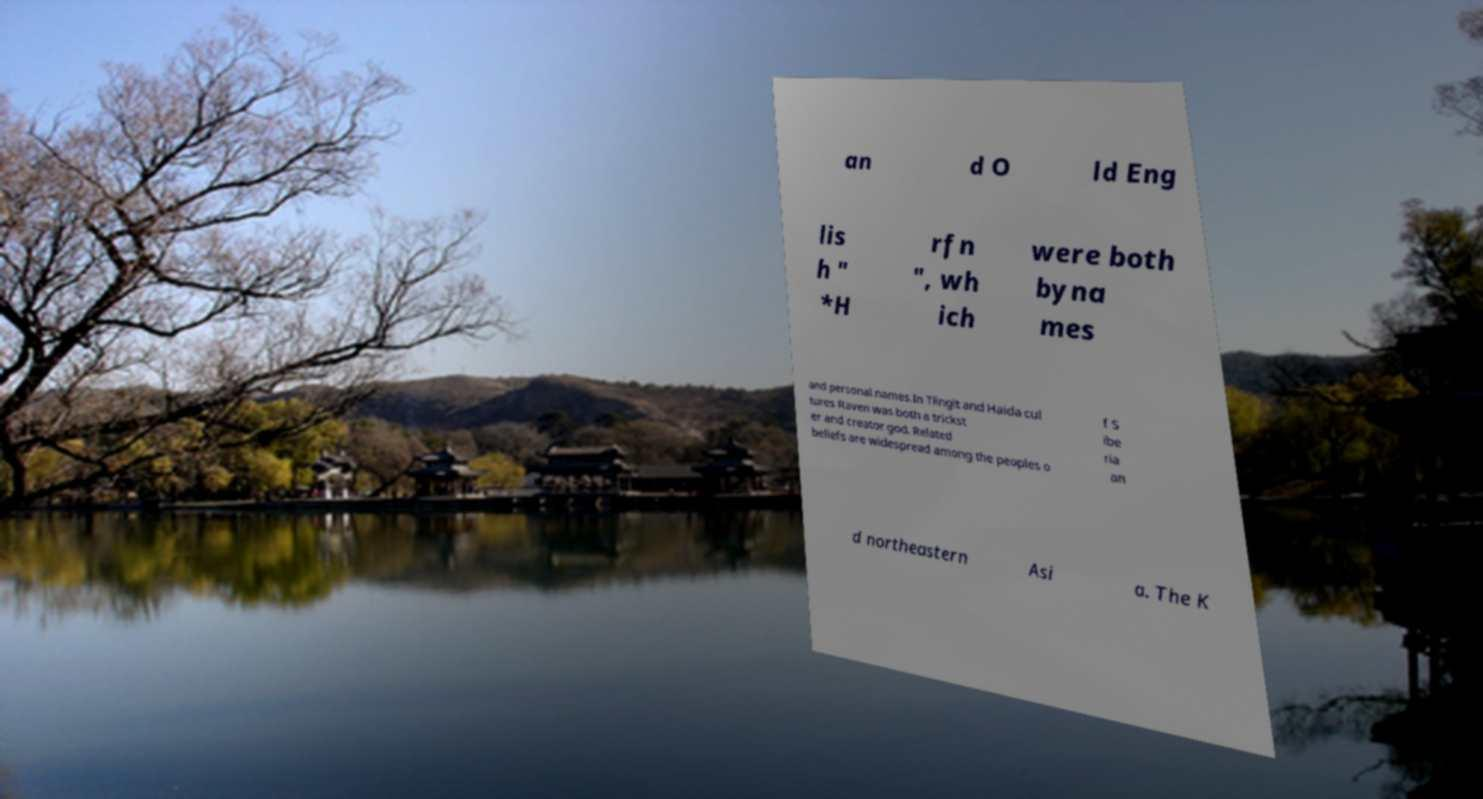Can you accurately transcribe the text from the provided image for me? an d O ld Eng lis h " *H rfn ", wh ich were both byna mes and personal names.In Tlingit and Haida cul tures Raven was both a trickst er and creator god. Related beliefs are widespread among the peoples o f S ibe ria an d northeastern Asi a. The K 